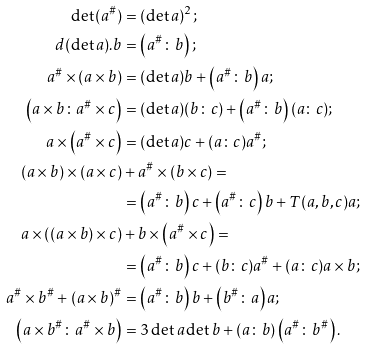Convert formula to latex. <formula><loc_0><loc_0><loc_500><loc_500>\det ( a ^ { \# } ) & = ( \det a ) ^ { 2 } ; \\ d ( \det a ) . b & = \left ( a ^ { \# } \colon b \right ) ; \\ a ^ { \# } \times ( a \times b ) & = ( \det a ) b + \left ( a ^ { \# } \colon b \right ) a ; \\ \left ( a \times b \colon a ^ { \# } \times c \right ) & = ( \det a ) ( b \colon c ) + \left ( a ^ { \# } \colon b \right ) ( a \colon c ) ; \\ a \times \left ( a ^ { \# } \times c \right ) & = ( \det a ) c + ( a \colon c ) a ^ { \# } ; \\ ( a \times b ) \times ( a \times c ) & + a ^ { \# } \times ( b \times c ) = \\ & = \left ( a ^ { \# } \colon b \right ) c + \left ( a ^ { \# } \colon c \right ) b + T ( a , b , c ) a ; \\ a \times \left ( \left ( a \times b \right ) \times c \right ) & + b \times \left ( a ^ { \# } \times c \right ) = \\ & = \left ( a ^ { \# } \colon b \right ) c + ( b \colon c ) a ^ { \# } + ( a \colon c ) a \times b ; \\ a ^ { \# } \times b ^ { \# } + ( a \times b ) ^ { \# } & = \left ( a ^ { \# } \colon b \right ) b + \left ( b ^ { \# } \colon a \right ) a ; \\ \left ( a \times b ^ { \# } \colon a ^ { \# } \times b \right ) & = 3 \det a \det b + ( a \colon b ) \left ( a ^ { \# } \colon b ^ { \# } \right ) .</formula> 